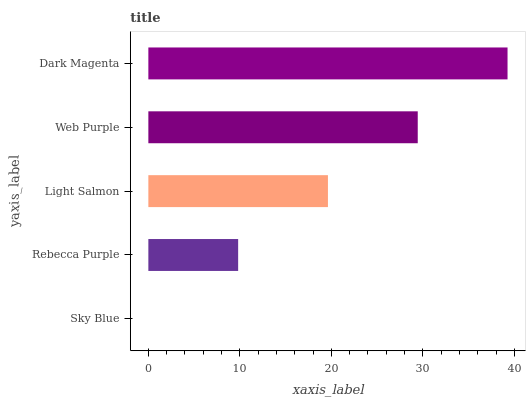Is Sky Blue the minimum?
Answer yes or no. Yes. Is Dark Magenta the maximum?
Answer yes or no. Yes. Is Rebecca Purple the minimum?
Answer yes or no. No. Is Rebecca Purple the maximum?
Answer yes or no. No. Is Rebecca Purple greater than Sky Blue?
Answer yes or no. Yes. Is Sky Blue less than Rebecca Purple?
Answer yes or no. Yes. Is Sky Blue greater than Rebecca Purple?
Answer yes or no. No. Is Rebecca Purple less than Sky Blue?
Answer yes or no. No. Is Light Salmon the high median?
Answer yes or no. Yes. Is Light Salmon the low median?
Answer yes or no. Yes. Is Rebecca Purple the high median?
Answer yes or no. No. Is Sky Blue the low median?
Answer yes or no. No. 